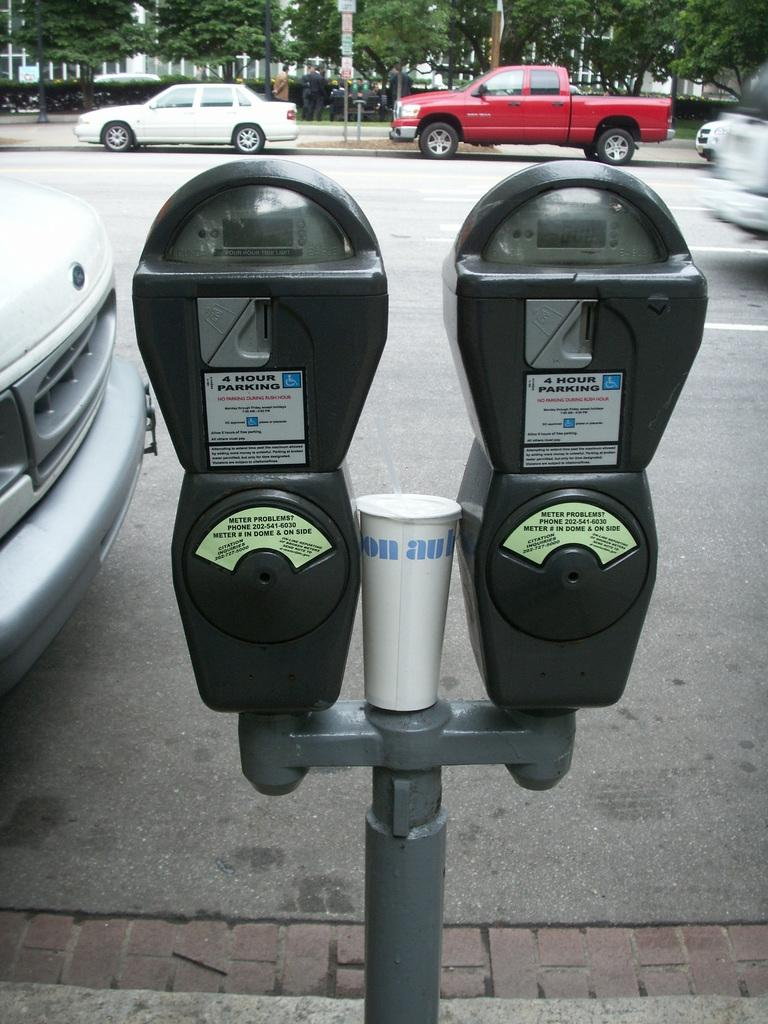<image>
Create a compact narrative representing the image presented. A double parking meter that says if you have problems call 202-541-6030. 